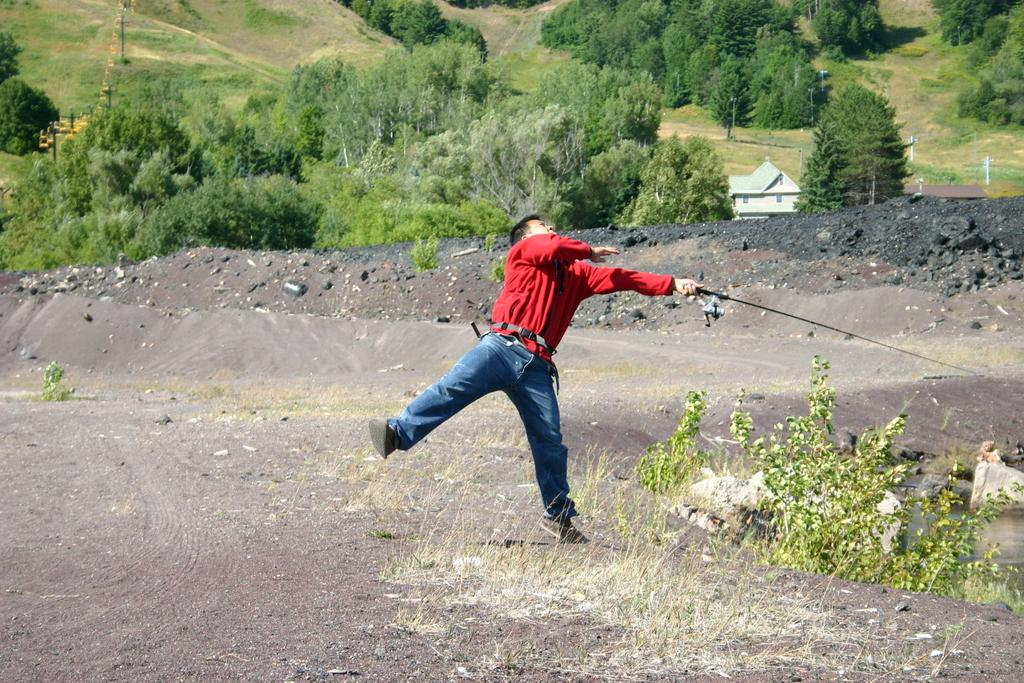What is the person in the image holding? The person in the image is holding objects. What can be seen beneath the person's feet in the image? The ground is visible in the image, and grass is present on the ground. What type of vegetation is visible in the image? Plants, trees, and grass are visible in the image. What other natural elements can be seen in the image? Rocks and water are visible in the image. What type of structure is present in the image? There is a house in the image. What man-made objects are present in the image? Poles are present in the image. How much money is hanging from the cobweb in the image? There is no cobweb or money present in the image. What type of shock can be seen affecting the person in the image? There is no shock or any indication of an electrical shock in the image. 